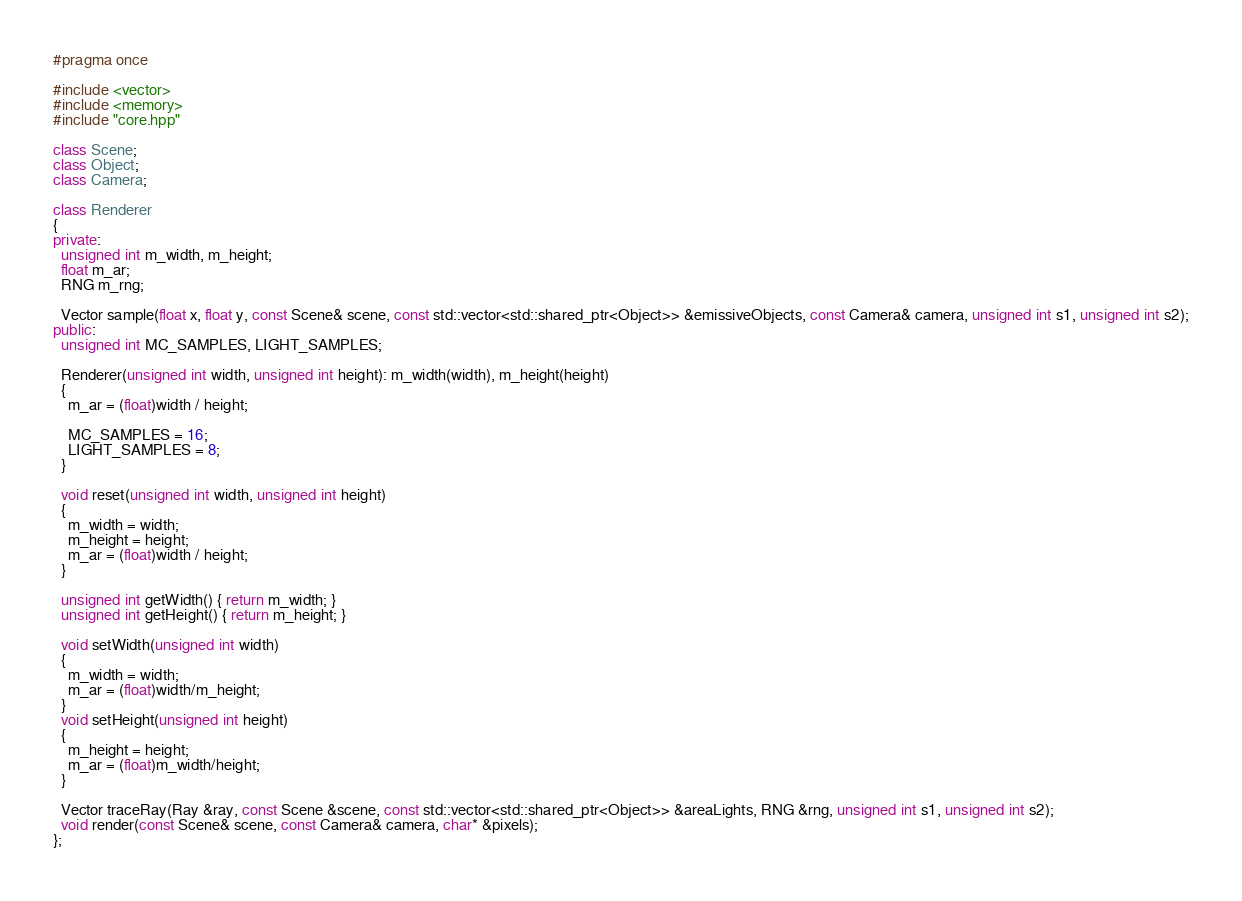Convert code to text. <code><loc_0><loc_0><loc_500><loc_500><_C++_>#pragma once

#include <vector>
#include <memory>
#include "core.hpp"

class Scene;
class Object;
class Camera;

class Renderer
{
private:
  unsigned int m_width, m_height;
  float m_ar;
  RNG m_rng;

  Vector sample(float x, float y, const Scene& scene, const std::vector<std::shared_ptr<Object>> &emissiveObjects, const Camera& camera, unsigned int s1, unsigned int s2);
public:
  unsigned int MC_SAMPLES, LIGHT_SAMPLES;

  Renderer(unsigned int width, unsigned int height): m_width(width), m_height(height)
  {
    m_ar = (float)width / height;

    MC_SAMPLES = 16;
    LIGHT_SAMPLES = 8;
  }

  void reset(unsigned int width, unsigned int height)
  {
    m_width = width;
    m_height = height;
    m_ar = (float)width / height;
  }

  unsigned int getWidth() { return m_width; }
  unsigned int getHeight() { return m_height; }

  void setWidth(unsigned int width)
  {
    m_width = width;
    m_ar = (float)width/m_height;
  }
  void setHeight(unsigned int height)
  {
    m_height = height;
    m_ar = (float)m_width/height;
  }

  Vector traceRay(Ray &ray, const Scene &scene, const std::vector<std::shared_ptr<Object>> &areaLights, RNG &rng, unsigned int s1, unsigned int s2);
  void render(const Scene& scene, const Camera& camera, char* &pixels);
};
</code> 